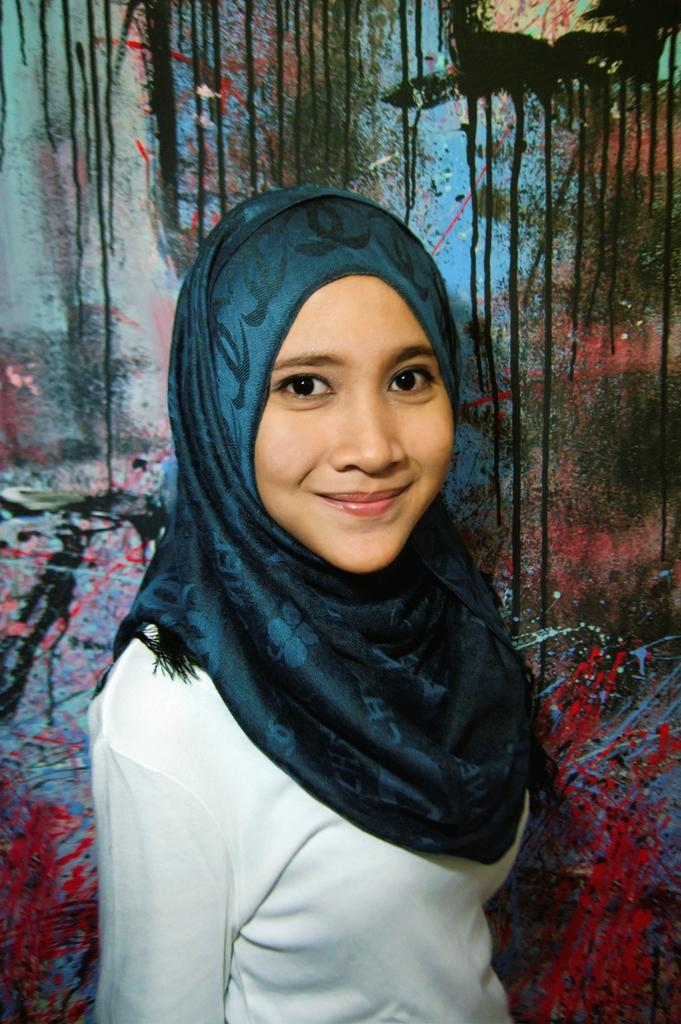Who is the main subject in the image? There is a girl in the image. What is the girl wearing? The girl is wearing clothes and a scarf. What can be seen on the wall in the image? There is a painting on the wall in the image. What invention is the girl holding in her hand in the image? There is no invention visible in the girl's hand in the image. What type of pencil can be seen in the image? There is no pencil present in the image. 